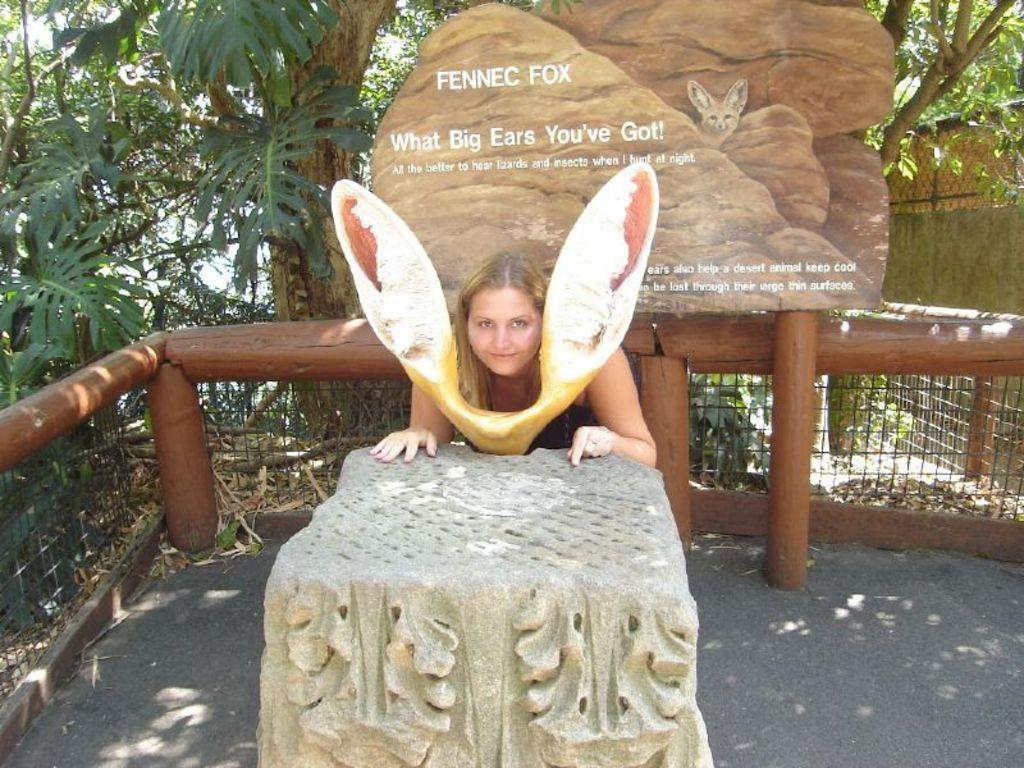Who is the main subject in the image? There is a woman in the center of the image. What can be found on the ground in the image? There is a statue on the ground. What type of natural elements can be seen in the background? Trees are visible in the background. What architectural feature is present in the background? Fencing is present in the background. What other living organisms can be seen in the background? Plants are present in the background. What type of toothbrush is the woman using in the image? There is no toothbrush present in the image. What color is the copper kitty in the image? There is no kitty, let alone a copper one, present in the image. 